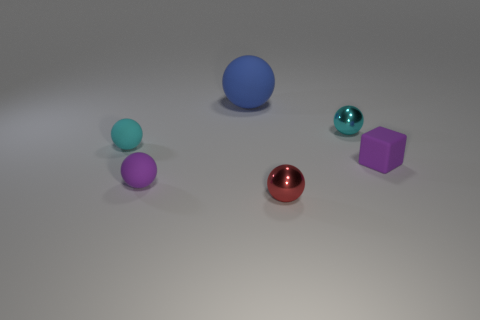Subtract all cyan spheres. How many were subtracted if there are1cyan spheres left? 1 Subtract all blue balls. How many balls are left? 4 Add 2 small green matte cylinders. How many objects exist? 8 Subtract all gray cylinders. How many cyan balls are left? 2 Subtract all purple balls. How many balls are left? 4 Subtract all blocks. How many objects are left? 5 Subtract all tiny purple shiny things. Subtract all red shiny balls. How many objects are left? 5 Add 4 red metal balls. How many red metal balls are left? 5 Add 1 small cyan rubber objects. How many small cyan rubber objects exist? 2 Subtract 0 gray cylinders. How many objects are left? 6 